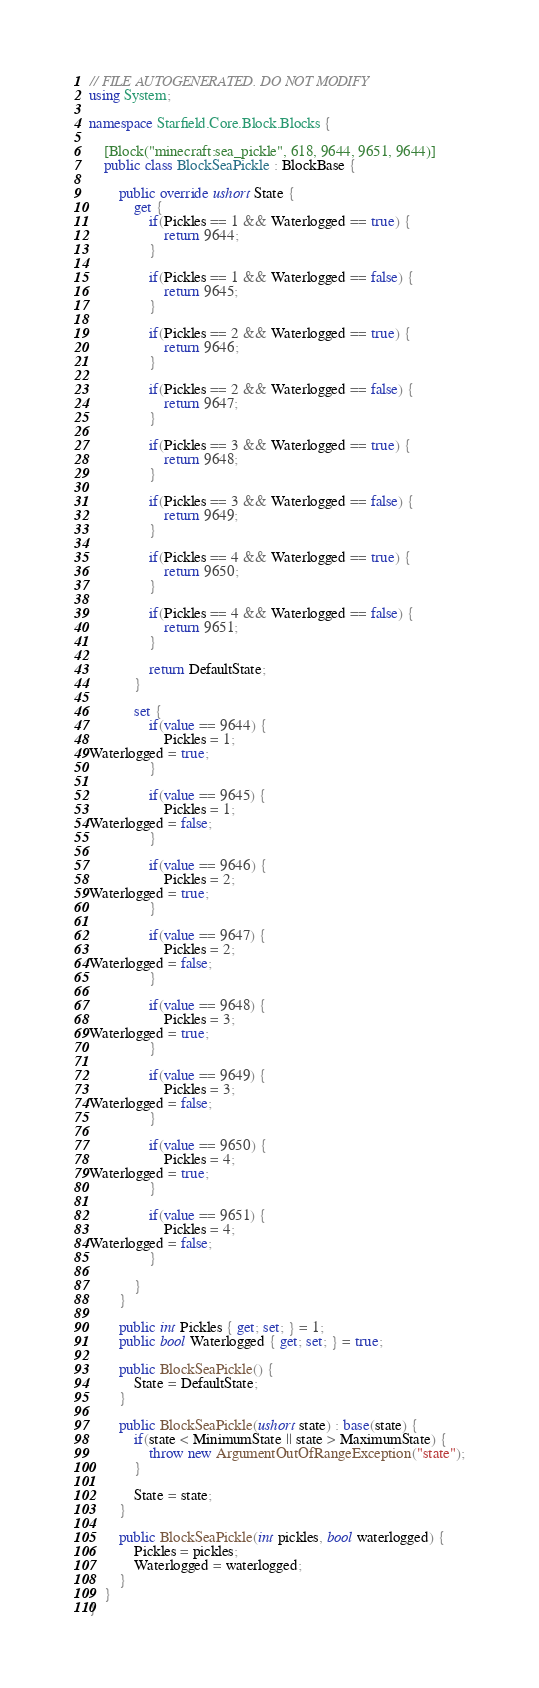Convert code to text. <code><loc_0><loc_0><loc_500><loc_500><_C#_>// FILE AUTOGENERATED. DO NOT MODIFY
using System;

namespace Starfield.Core.Block.Blocks {

    [Block("minecraft:sea_pickle", 618, 9644, 9651, 9644)]
    public class BlockSeaPickle : BlockBase {

        public override ushort State {
            get {
                if(Pickles == 1 && Waterlogged == true) {
                    return 9644;
                }

                if(Pickles == 1 && Waterlogged == false) {
                    return 9645;
                }

                if(Pickles == 2 && Waterlogged == true) {
                    return 9646;
                }

                if(Pickles == 2 && Waterlogged == false) {
                    return 9647;
                }

                if(Pickles == 3 && Waterlogged == true) {
                    return 9648;
                }

                if(Pickles == 3 && Waterlogged == false) {
                    return 9649;
                }

                if(Pickles == 4 && Waterlogged == true) {
                    return 9650;
                }

                if(Pickles == 4 && Waterlogged == false) {
                    return 9651;
                }

                return DefaultState;
            }

            set {
                if(value == 9644) {
                    Pickles = 1;
Waterlogged = true;
                }

                if(value == 9645) {
                    Pickles = 1;
Waterlogged = false;
                }

                if(value == 9646) {
                    Pickles = 2;
Waterlogged = true;
                }

                if(value == 9647) {
                    Pickles = 2;
Waterlogged = false;
                }

                if(value == 9648) {
                    Pickles = 3;
Waterlogged = true;
                }

                if(value == 9649) {
                    Pickles = 3;
Waterlogged = false;
                }

                if(value == 9650) {
                    Pickles = 4;
Waterlogged = true;
                }

                if(value == 9651) {
                    Pickles = 4;
Waterlogged = false;
                }

            }
        }

        public int Pickles { get; set; } = 1;
        public bool Waterlogged { get; set; } = true;

        public BlockSeaPickle() {
            State = DefaultState;
        }

        public BlockSeaPickle(ushort state) : base(state) {
            if(state < MinimumState || state > MaximumState) {
                throw new ArgumentOutOfRangeException("state");
            }

            State = state;
        }

        public BlockSeaPickle(int pickles, bool waterlogged) {
            Pickles = pickles;
            Waterlogged = waterlogged;
        }
    }
}</code> 